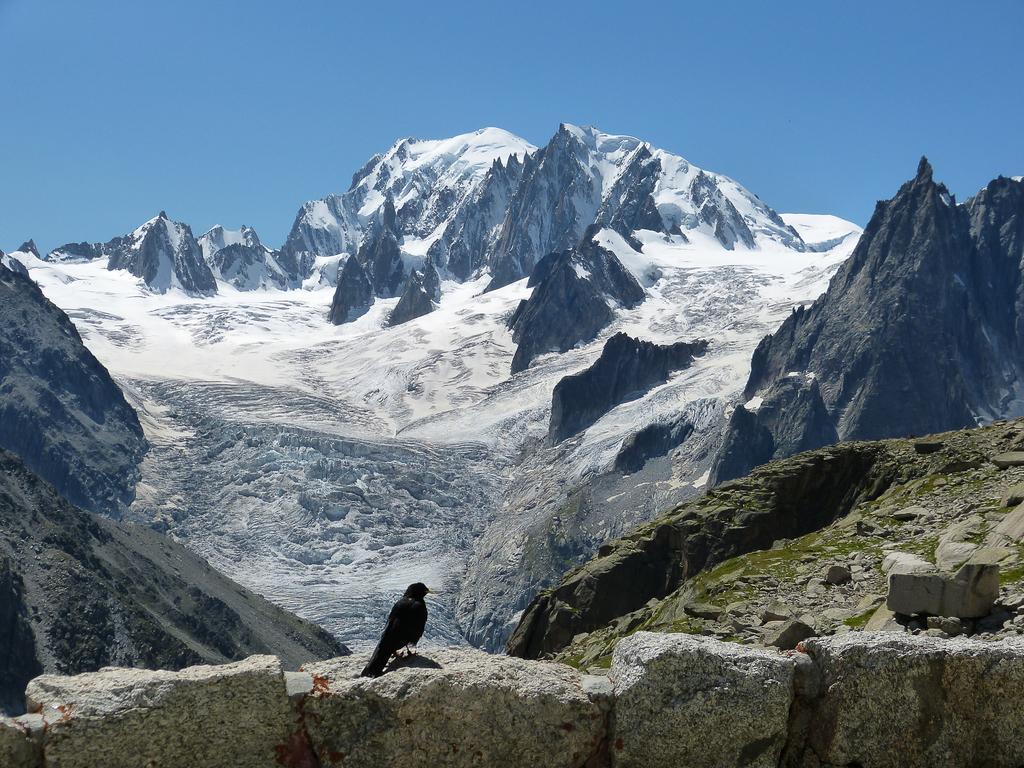Could you give a brief overview of what you see in this image? There is a black color bird on the rock, which is attached to the other rocks. In the background, there are snow mountains and there is blue sky. 